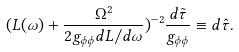<formula> <loc_0><loc_0><loc_500><loc_500>( L ( \omega ) + \frac { \Omega ^ { 2 } } { 2 g _ { \phi \phi } d L / d \omega } ) ^ { - 2 } \frac { d \tilde { \tau } } { g _ { \phi \phi } } \equiv d \hat { \tau } .</formula> 